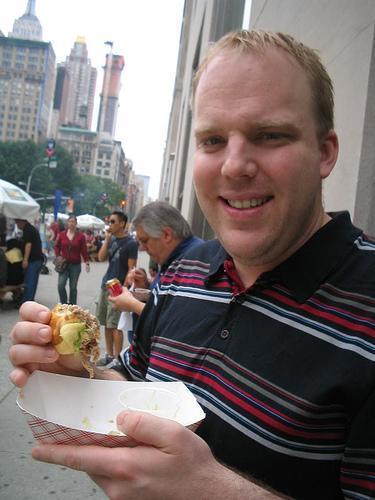How many people are in the picture?
Give a very brief answer. 3. 